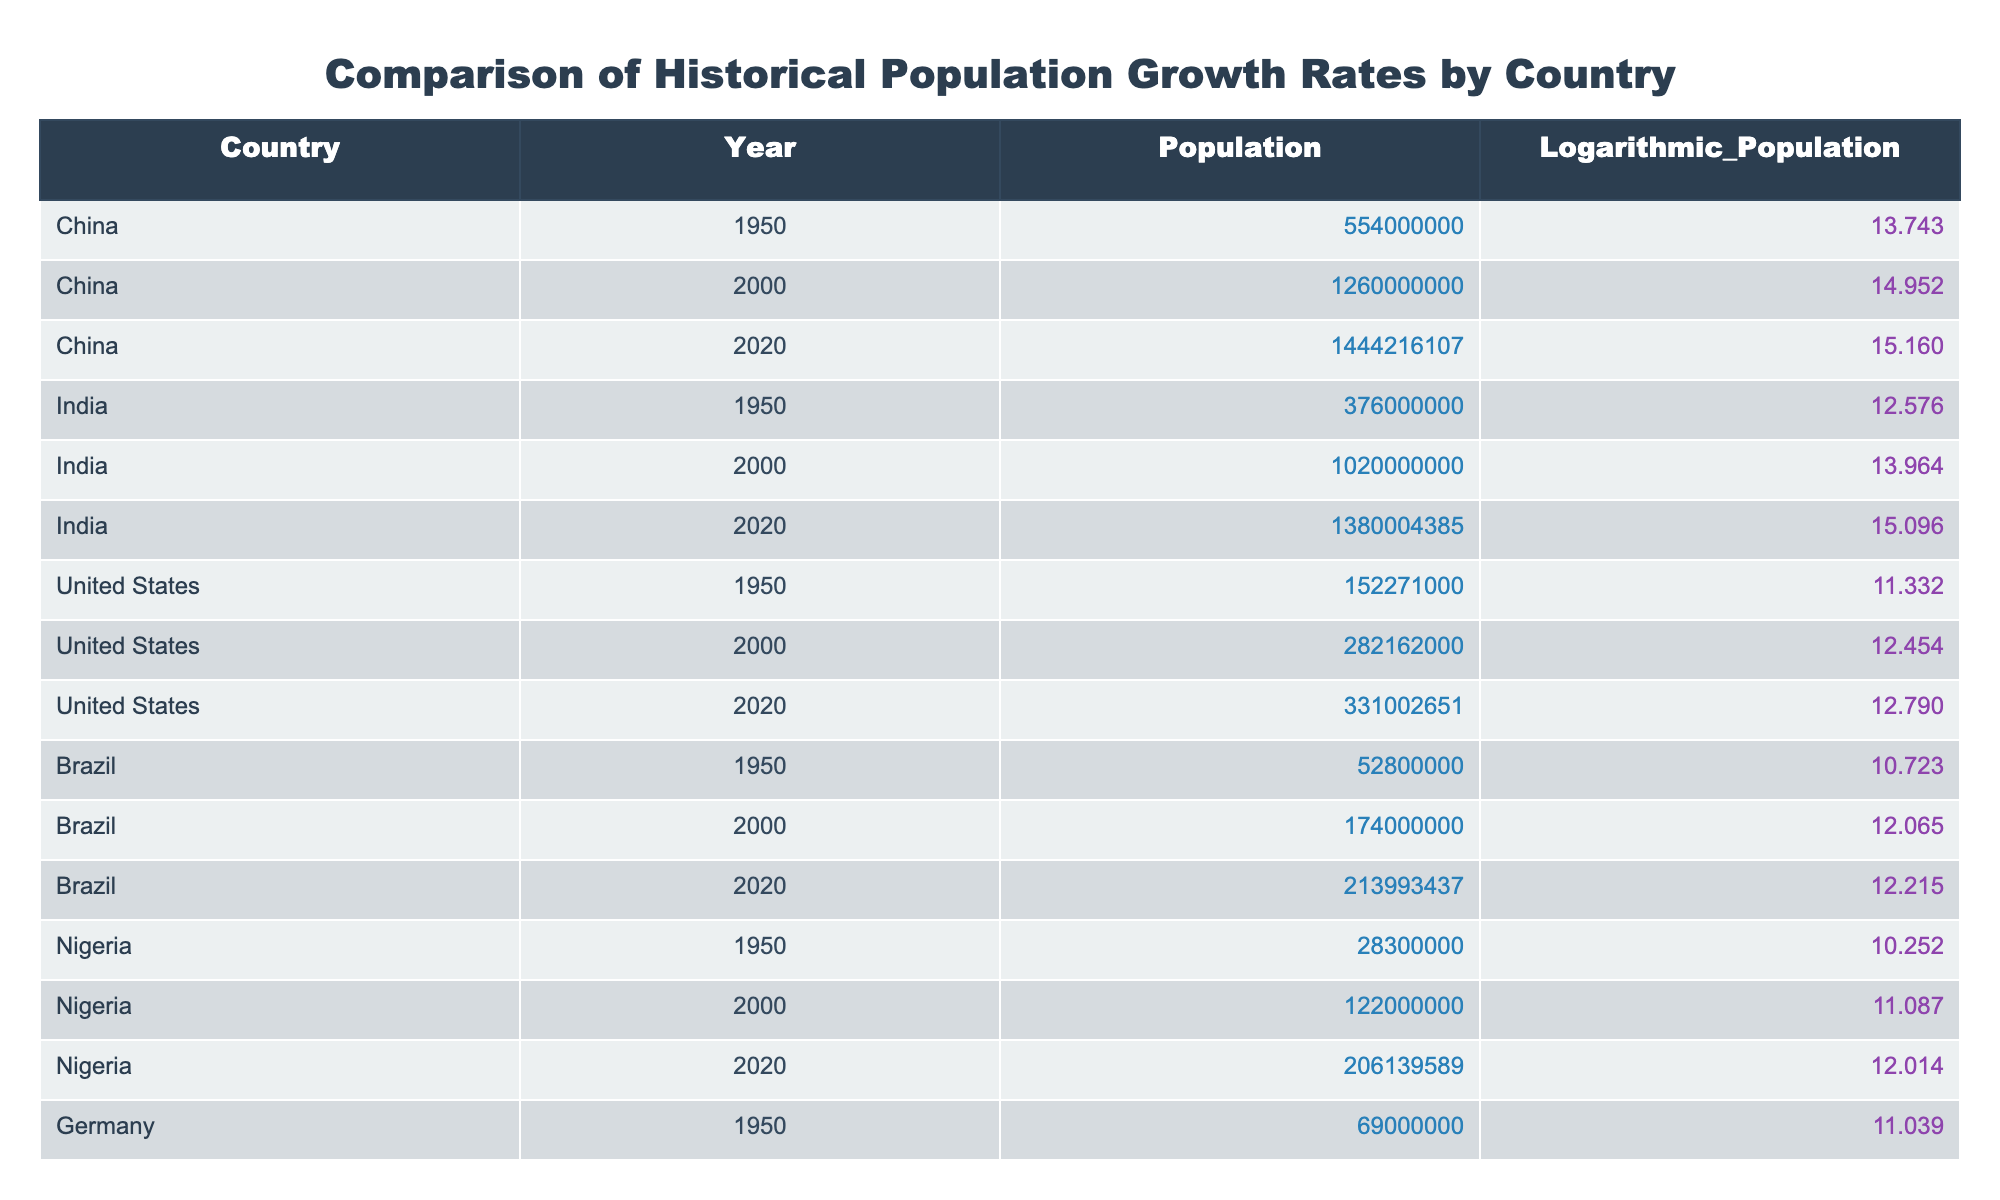What was the population of India in 1950? From the table, we can locate the row for India in the Year 1950. The population listed in that row is 376,000,000.
Answer: 376000000 Which country had the highest population in the year 2000? By examining the table for the year 2000, we see the populations: China (1,260,000,000), India (1,020,000,000), United States (282,162,000), Brazil (174,000,000), and Nigeria (122,000,000). China has the highest population among these values.
Answer: China What is the logarithmic population of Nigeria in 2020? The table shows the row for Nigeria in the Year 2020, where the logarithmic population is listed as 12.014.
Answer: 12.014 What is the average population of the United States from 1950 to 2020? To find the average, we need the populations from the table for the United States: 152,271,000 in 1950, 282,162,000 in 2000, and 331,002,651 in 2020. First, we sum these values: 152,271,000 + 282,162,000 + 331,002,651 = 765,435,651. Then, we divide by the number of years (3): 765,435,651 / 3 = 255,145,217.
Answer: 255145217 Was the population of Germany higher in 2000 than in 2020? By comparing the entries for Germany in the years 2000 and 2020, we find the population in 2000 is 82,600,000 and in 2020 is 83,783,942. Since 83,783,942 is greater than 82,600,000, the statement is true.
Answer: Yes Which country saw the highest increase in population from 1950 to 2020? We calculate the population difference for each country from 1950 to 2020: China (1,444,216,107 - 554,000,000), India (1,380,004,385 - 376,000,000), the United States (331,002,651 - 152,271,000), Brazil (213,993,437 - 52,800,000), and Nigeria (206,139,589 - 28,300,000). The calculations yield: China 890,216,107, India 1,004,004,385, United States 178,731,651, Brazil 161,193,437, Nigeria 177,839,589. The highest increase is for India.
Answer: India 